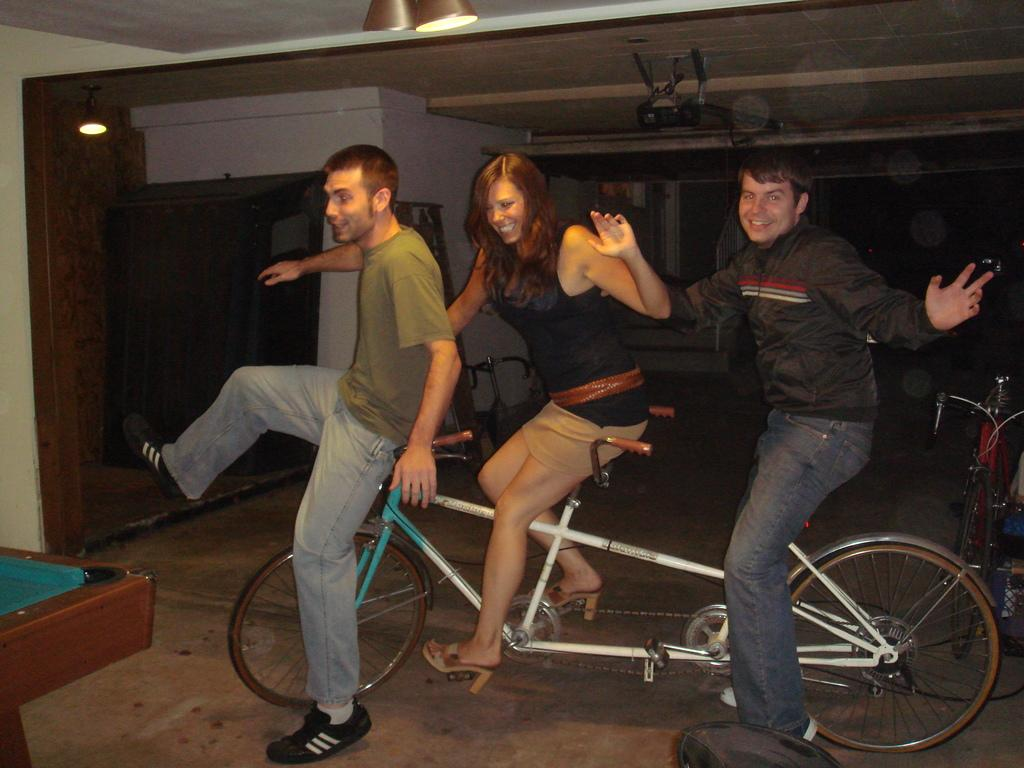How many people are in the image? There are three people in the image. Can you describe the gender of one of the people? One of the people is a woman. What are the three people doing in the image? The three people are sitting on a bicycle. What objects can be seen in the image besides the people? There is a projector and a light in the image. What is the purpose of the light in the image? The light is directed towards a wall. How many eggs are being used in the magic trick in the image? There is no magic trick or eggs present in the image. 